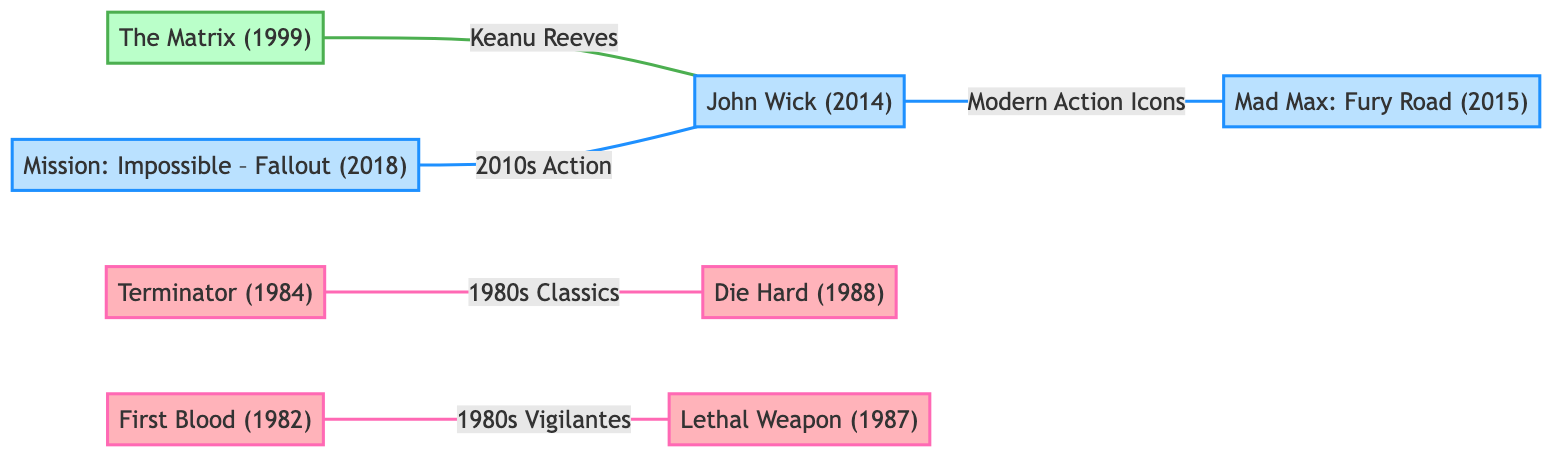What decade is "Die Hard" from? The node for "Die Hard" indicates that it is from the 1980s, as noted in the description.
Answer: 1980s Who portrayed the character in "Mad Max: Fury Road"? The node for "Mad Max: Fury Road" states that Tom Hardy portrayed Max Rockatansky in the film.
Answer: Tom Hardy How many nodes are there in the graph? Counting the nodes listed, there are a total of 8 unique characters from different decades.
Answer: 8 What is the relationship between "Terminator" and "Die Hard"? The edge connecting "Terminator" and "Die Hard" is labeled "1980s Classics," indicating they belong to the same category of films from that decade.
Answer: 1980s Classics Which character is linked to both "The Matrix" and "John Wick"? From the diagram, "John Wick" is connected to "The Matrix" indicating that they share the actor Keanu Reeves.
Answer: John Wick How many edges are there in the graph? Analyzing the connections represented by the edges, there are a total of 5 edges linking the different movies.
Answer: 5 What decade are both "Rambo" and "Lethal Weapon" from? Both nodes indicate that these movies are classified under the 1980s, referring to similar themes of vigilantes.
Answer: 1980s What does the relationship "2010s Action" refer to in the graph? The edge labeled "2010s Action" connects "Henry Cavill Mission Impossible" to "John Wick," suggesting a category of films featuring prominent action elements in that decade.
Answer: 2010s Action Which two characters are categorized as "Modern Action Icons"? The relationship labeled "Modern Action Icons" connects "John Wick" to "Mad Max," depicting these characters as modern representations of action hero archetypes.
Answer: John Wick and Mad Max 